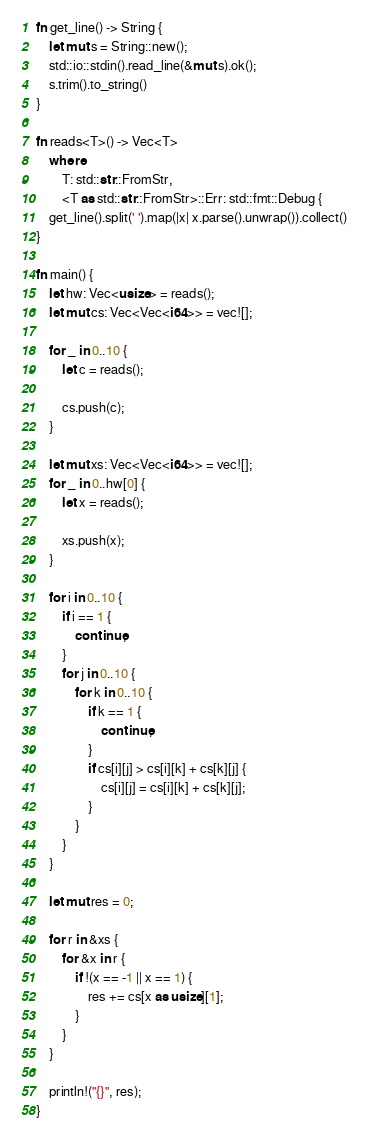Convert code to text. <code><loc_0><loc_0><loc_500><loc_500><_Rust_>fn get_line() -> String {
    let mut s = String::new();
    std::io::stdin().read_line(&mut s).ok();
    s.trim().to_string()
}

fn reads<T>() -> Vec<T>
    where
        T: std::str::FromStr,
        <T as std::str::FromStr>::Err: std::fmt::Debug {
    get_line().split(' ').map(|x| x.parse().unwrap()).collect()
}

fn main() {
    let hw: Vec<usize> = reads();
    let mut cs: Vec<Vec<i64>> = vec![];

    for _ in 0..10 {
        let c = reads();

        cs.push(c);
    }

    let mut xs: Vec<Vec<i64>> = vec![];
    for _ in 0..hw[0] {
        let x = reads();

        xs.push(x);
    }

    for i in 0..10 {
        if i == 1 {
            continue;
        }
        for j in 0..10 {
            for k in 0..10 {
                if k == 1 {
                    continue;
                }
                if cs[i][j] > cs[i][k] + cs[k][j] {
                    cs[i][j] = cs[i][k] + cs[k][j];
                }
            }
        }
    }

    let mut res = 0;

    for r in &xs {
        for &x in r {
            if !(x == -1 || x == 1) {
                res += cs[x as usize][1];
            }
        }
    }

    println!("{}", res);
}</code> 